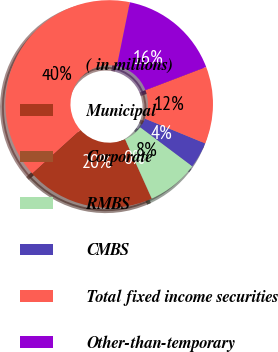Convert chart to OTSL. <chart><loc_0><loc_0><loc_500><loc_500><pie_chart><fcel>( in millions)<fcel>Municipal<fcel>Corporate<fcel>RMBS<fcel>CMBS<fcel>Total fixed income securities<fcel>Other-than-temporary<nl><fcel>39.93%<fcel>19.98%<fcel>0.04%<fcel>8.02%<fcel>4.03%<fcel>12.01%<fcel>16.0%<nl></chart> 